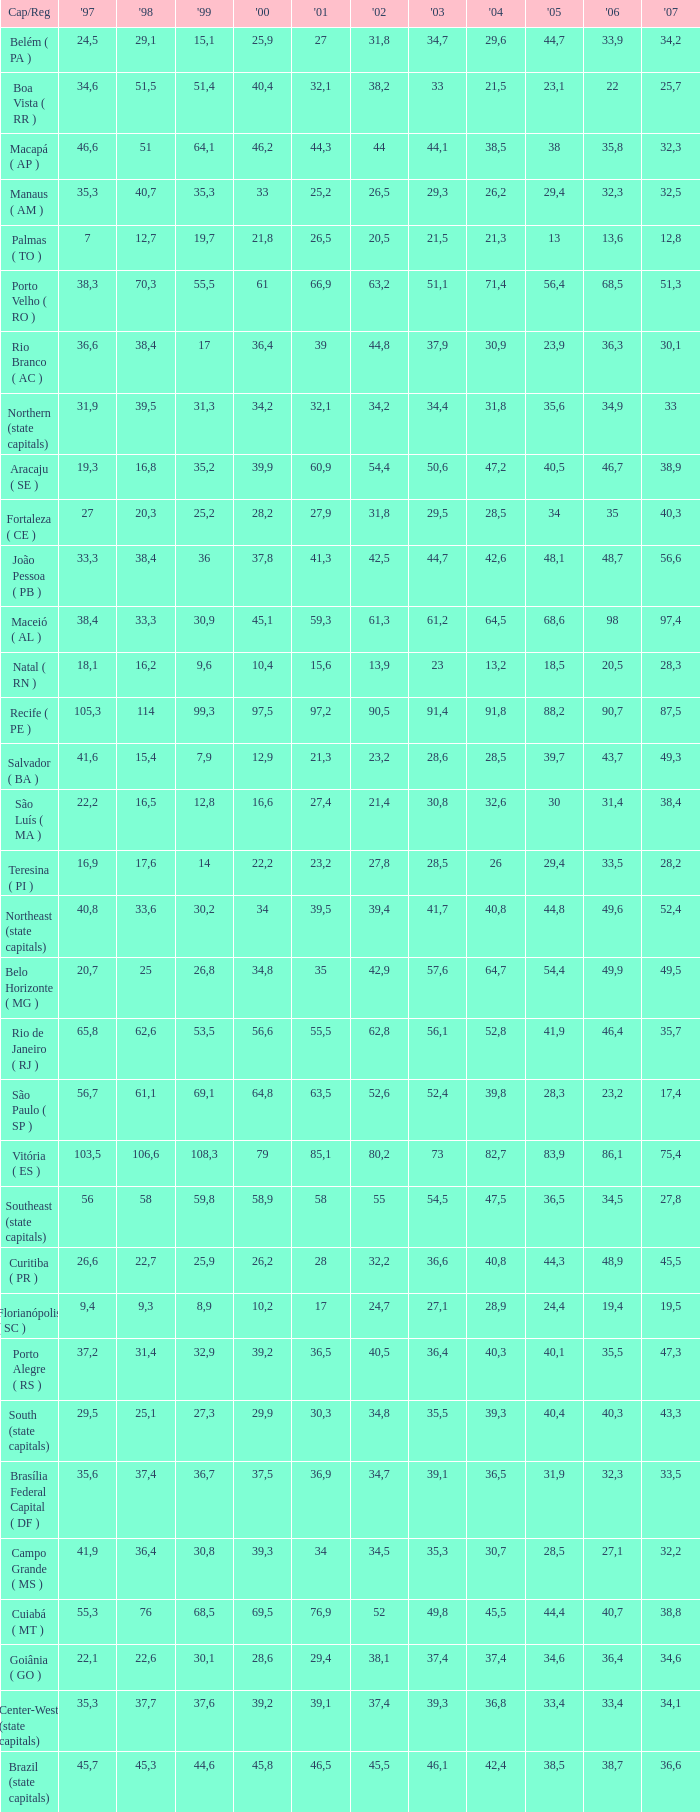How many 2007's have a 2003 less than 36,4, 27,9 as a 2001, and a 1999 less than 25,2? None. Can you give me this table as a dict? {'header': ['Cap/Reg', "'97", "'98", "'99", "'00", "'01", "'02", "'03", "'04", "'05", "'06", "'07"], 'rows': [['Belém ( PA )', '24,5', '29,1', '15,1', '25,9', '27', '31,8', '34,7', '29,6', '44,7', '33,9', '34,2'], ['Boa Vista ( RR )', '34,6', '51,5', '51,4', '40,4', '32,1', '38,2', '33', '21,5', '23,1', '22', '25,7'], ['Macapá ( AP )', '46,6', '51', '64,1', '46,2', '44,3', '44', '44,1', '38,5', '38', '35,8', '32,3'], ['Manaus ( AM )', '35,3', '40,7', '35,3', '33', '25,2', '26,5', '29,3', '26,2', '29,4', '32,3', '32,5'], ['Palmas ( TO )', '7', '12,7', '19,7', '21,8', '26,5', '20,5', '21,5', '21,3', '13', '13,6', '12,8'], ['Porto Velho ( RO )', '38,3', '70,3', '55,5', '61', '66,9', '63,2', '51,1', '71,4', '56,4', '68,5', '51,3'], ['Rio Branco ( AC )', '36,6', '38,4', '17', '36,4', '39', '44,8', '37,9', '30,9', '23,9', '36,3', '30,1'], ['Northern (state capitals)', '31,9', '39,5', '31,3', '34,2', '32,1', '34,2', '34,4', '31,8', '35,6', '34,9', '33'], ['Aracaju ( SE )', '19,3', '16,8', '35,2', '39,9', '60,9', '54,4', '50,6', '47,2', '40,5', '46,7', '38,9'], ['Fortaleza ( CE )', '27', '20,3', '25,2', '28,2', '27,9', '31,8', '29,5', '28,5', '34', '35', '40,3'], ['João Pessoa ( PB )', '33,3', '38,4', '36', '37,8', '41,3', '42,5', '44,7', '42,6', '48,1', '48,7', '56,6'], ['Maceió ( AL )', '38,4', '33,3', '30,9', '45,1', '59,3', '61,3', '61,2', '64,5', '68,6', '98', '97,4'], ['Natal ( RN )', '18,1', '16,2', '9,6', '10,4', '15,6', '13,9', '23', '13,2', '18,5', '20,5', '28,3'], ['Recife ( PE )', '105,3', '114', '99,3', '97,5', '97,2', '90,5', '91,4', '91,8', '88,2', '90,7', '87,5'], ['Salvador ( BA )', '41,6', '15,4', '7,9', '12,9', '21,3', '23,2', '28,6', '28,5', '39,7', '43,7', '49,3'], ['São Luís ( MA )', '22,2', '16,5', '12,8', '16,6', '27,4', '21,4', '30,8', '32,6', '30', '31,4', '38,4'], ['Teresina ( PI )', '16,9', '17,6', '14', '22,2', '23,2', '27,8', '28,5', '26', '29,4', '33,5', '28,2'], ['Northeast (state capitals)', '40,8', '33,6', '30,2', '34', '39,5', '39,4', '41,7', '40,8', '44,8', '49,6', '52,4'], ['Belo Horizonte ( MG )', '20,7', '25', '26,8', '34,8', '35', '42,9', '57,6', '64,7', '54,4', '49,9', '49,5'], ['Rio de Janeiro ( RJ )', '65,8', '62,6', '53,5', '56,6', '55,5', '62,8', '56,1', '52,8', '41,9', '46,4', '35,7'], ['São Paulo ( SP )', '56,7', '61,1', '69,1', '64,8', '63,5', '52,6', '52,4', '39,8', '28,3', '23,2', '17,4'], ['Vitória ( ES )', '103,5', '106,6', '108,3', '79', '85,1', '80,2', '73', '82,7', '83,9', '86,1', '75,4'], ['Southeast (state capitals)', '56', '58', '59,8', '58,9', '58', '55', '54,5', '47,5', '36,5', '34,5', '27,8'], ['Curitiba ( PR )', '26,6', '22,7', '25,9', '26,2', '28', '32,2', '36,6', '40,8', '44,3', '48,9', '45,5'], ['Florianópolis ( SC )', '9,4', '9,3', '8,9', '10,2', '17', '24,7', '27,1', '28,9', '24,4', '19,4', '19,5'], ['Porto Alegre ( RS )', '37,2', '31,4', '32,9', '39,2', '36,5', '40,5', '36,4', '40,3', '40,1', '35,5', '47,3'], ['South (state capitals)', '29,5', '25,1', '27,3', '29,9', '30,3', '34,8', '35,5', '39,3', '40,4', '40,3', '43,3'], ['Brasília Federal Capital ( DF )', '35,6', '37,4', '36,7', '37,5', '36,9', '34,7', '39,1', '36,5', '31,9', '32,3', '33,5'], ['Campo Grande ( MS )', '41,9', '36,4', '30,8', '39,3', '34', '34,5', '35,3', '30,7', '28,5', '27,1', '32,2'], ['Cuiabá ( MT )', '55,3', '76', '68,5', '69,5', '76,9', '52', '49,8', '45,5', '44,4', '40,7', '38,8'], ['Goiânia ( GO )', '22,1', '22,6', '30,1', '28,6', '29,4', '38,1', '37,4', '37,4', '34,6', '36,4', '34,6'], ['Center-West (state capitals)', '35,3', '37,7', '37,6', '39,2', '39,1', '37,4', '39,3', '36,8', '33,4', '33,4', '34,1'], ['Brazil (state capitals)', '45,7', '45,3', '44,6', '45,8', '46,5', '45,5', '46,1', '42,4', '38,5', '38,7', '36,6']]} 